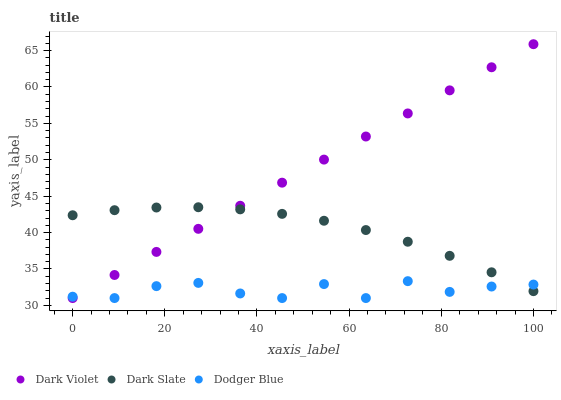Does Dodger Blue have the minimum area under the curve?
Answer yes or no. Yes. Does Dark Violet have the maximum area under the curve?
Answer yes or no. Yes. Does Dark Violet have the minimum area under the curve?
Answer yes or no. No. Does Dodger Blue have the maximum area under the curve?
Answer yes or no. No. Is Dark Violet the smoothest?
Answer yes or no. Yes. Is Dodger Blue the roughest?
Answer yes or no. Yes. Is Dodger Blue the smoothest?
Answer yes or no. No. Is Dark Violet the roughest?
Answer yes or no. No. Does Dodger Blue have the lowest value?
Answer yes or no. Yes. Does Dark Violet have the highest value?
Answer yes or no. Yes. Does Dodger Blue have the highest value?
Answer yes or no. No. Does Dodger Blue intersect Dark Violet?
Answer yes or no. Yes. Is Dodger Blue less than Dark Violet?
Answer yes or no. No. Is Dodger Blue greater than Dark Violet?
Answer yes or no. No. 